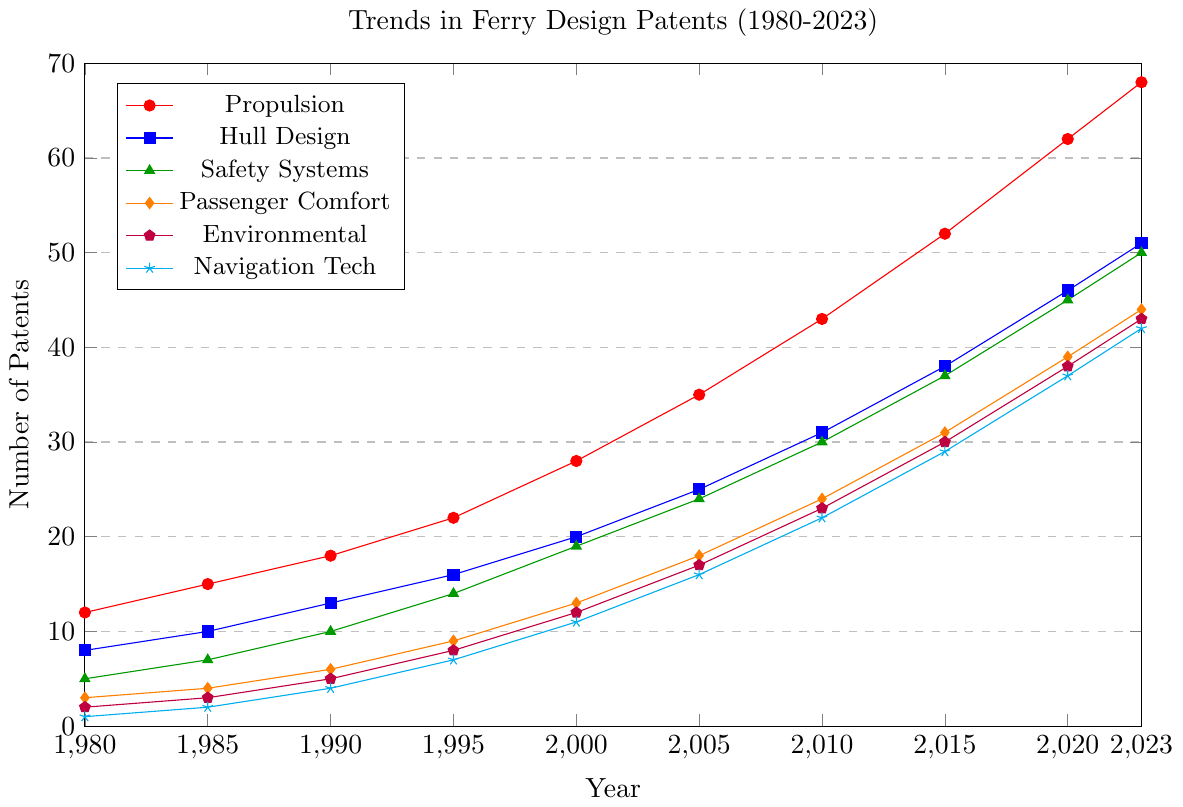What's the trend in the number of patents filed for Hull Design from 1980 to 2023? By observing the line representing Hull Design, it's clear that the trend is increasing. Starting at 8 patents in 1980 and reaching 51 patents in 2023, there is a consistent upward trend.
Answer: Increasing Which innovation category had the highest number of patents filed in 2023? By looking at the endpoints of all the lines in 2023, the line for Propulsion reaches the highest point at 68 patents.
Answer: Propulsion How many total patents were filed across all categories in 2005? Sum the number of patents filed in each category for the year 2005: Propulsion (35), Hull Design (25), Safety Systems (24), Passenger Comfort (18), Environmental (17), and Navigation Tech (16). Summing these gives 135.
Answer: 135 Is the number of patents filed for Environmental innovations in 2023 greater than the number of patents filed for Safety Systems in 2015? The number of Environmental patents in 2023 is 43. The number of Safety Systems patents in 2015 is 37. Comparing these two values, 43 is greater than 37.
Answer: Yes What is the percentage increase in the number of Navigation Tech patents from 1980 to 2023? The number of Navigation Tech patents in 1980 was 1, and in 2023 it is 42. The increase is 42 - 1 = 41. The percentage increase is (41/1) * 100% = 4100%.
Answer: 4100% Which category showed the most consistent rate of increase in patents from 1980 to 2023? By observing the smoothness and uniform slope of the lines, Safety Systems shows a consistent linear increase from 5 in 1980 to 50 in 2023, without sudden jumps or drops.
Answer: Safety Systems How does the number of Passenger Comfort patents in 2020 compare to the number of Hull Design patents in 1995? Passenger Comfort patents in 2020 are 39, while Hull Design patents in 1995 are 16. Comparing these, 39 is greater than 16.
Answer: Passenger Comfort patents in 2020 are greater What was the average number of Safety Systems patents filed per year from 1980 to 2023? To find the average, sum the number of Safety Systems patents from all years and divide by the number of years: (5+7+10+14+19+24+30+37+45+50) = 241. There are 10 years, so the average is 241 / 10 = 24.1.
Answer: 24.1 Between which consecutive periods did Propulsion patents show the greatest increase? By calculating the differences between consecutive years for Propulsion: 
1985-1980: 15-12 = 3, 
1990-1985: 18-15 = 3, 
1995-1990: 22-18 = 4, 
2000-1995: 28-22 = 6, 
2005-2000: 35-28 = 7, 
2010-2005: 43-35 = 8, 
2015-2010: 52-43 = 9, 
2020-2015: 62-52 = 10, 
2023-2020: 68-62 = 6. 
The greatest increase was between 2015 and 2020 with an increment of 10.
Answer: 2015-2020 